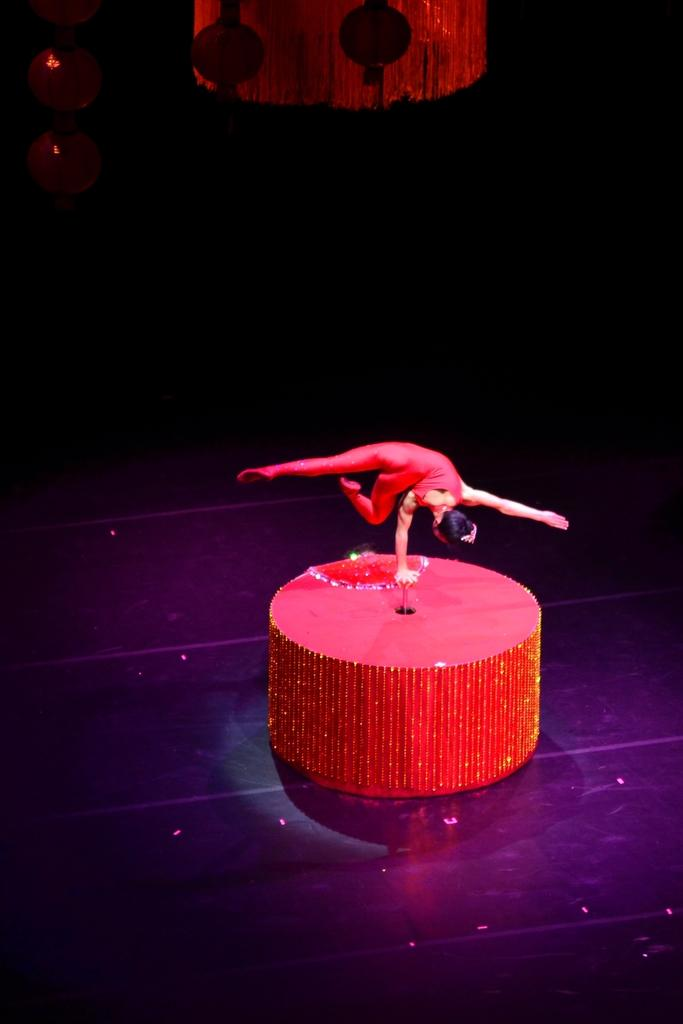Who is present in the image? There is a lady in the image. What is the lady standing near? There is a table in the image. Can you describe any objects visible at the top of the image? Unfortunately, the provided facts do not give any information about objects at the top of the image. What type of substance can be seen flowing through the hole in the image? There is no hole or substance present in the image. 